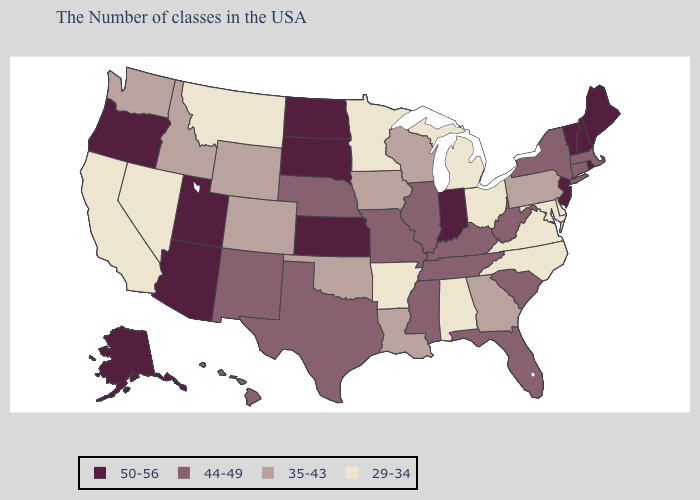Name the states that have a value in the range 50-56?
Quick response, please. Maine, Rhode Island, New Hampshire, Vermont, New Jersey, Indiana, Kansas, South Dakota, North Dakota, Utah, Arizona, Oregon, Alaska. Name the states that have a value in the range 29-34?
Be succinct. Delaware, Maryland, Virginia, North Carolina, Ohio, Michigan, Alabama, Arkansas, Minnesota, Montana, Nevada, California. What is the value of Michigan?
Give a very brief answer. 29-34. Among the states that border Illinois , does Indiana have the highest value?
Be succinct. Yes. What is the value of Vermont?
Be succinct. 50-56. Name the states that have a value in the range 50-56?
Short answer required. Maine, Rhode Island, New Hampshire, Vermont, New Jersey, Indiana, Kansas, South Dakota, North Dakota, Utah, Arizona, Oregon, Alaska. What is the lowest value in the South?
Answer briefly. 29-34. What is the highest value in states that border Tennessee?
Keep it brief. 44-49. Name the states that have a value in the range 44-49?
Write a very short answer. Massachusetts, Connecticut, New York, South Carolina, West Virginia, Florida, Kentucky, Tennessee, Illinois, Mississippi, Missouri, Nebraska, Texas, New Mexico, Hawaii. Which states have the lowest value in the USA?
Give a very brief answer. Delaware, Maryland, Virginia, North Carolina, Ohio, Michigan, Alabama, Arkansas, Minnesota, Montana, Nevada, California. What is the lowest value in states that border Montana?
Answer briefly. 35-43. Does the map have missing data?
Give a very brief answer. No. What is the value of West Virginia?
Quick response, please. 44-49. Does California have the highest value in the West?
Short answer required. No. Name the states that have a value in the range 35-43?
Give a very brief answer. Pennsylvania, Georgia, Wisconsin, Louisiana, Iowa, Oklahoma, Wyoming, Colorado, Idaho, Washington. 